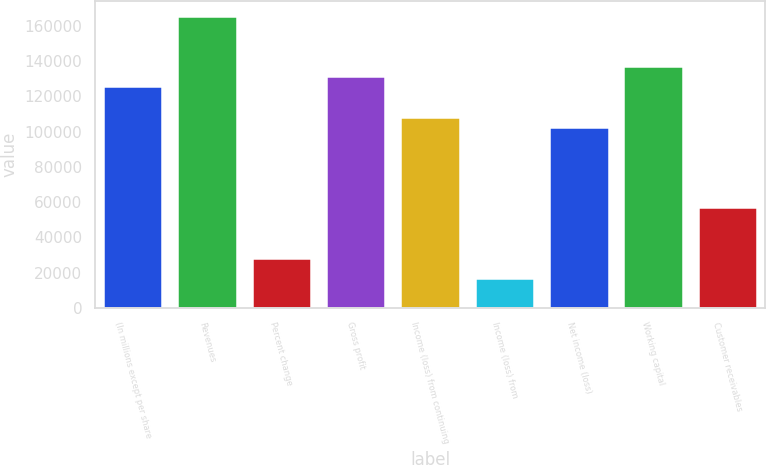<chart> <loc_0><loc_0><loc_500><loc_500><bar_chart><fcel>(In millions except per share<fcel>Revenues<fcel>Percent change<fcel>Gross profit<fcel>Income (loss) from continuing<fcel>Income (loss) from<fcel>Net income (loss)<fcel>Working capital<fcel>Customer receivables<nl><fcel>125569<fcel>165523<fcel>28538.6<fcel>131277<fcel>108446<fcel>17123.3<fcel>102738<fcel>136985<fcel>57077<nl></chart> 